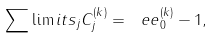Convert formula to latex. <formula><loc_0><loc_0><loc_500><loc_500>\sum \lim i t s _ { j } { C _ { j } ^ { ( k ) } } = { \ e e } _ { 0 } ^ { ( k ) } - 1 ,</formula> 